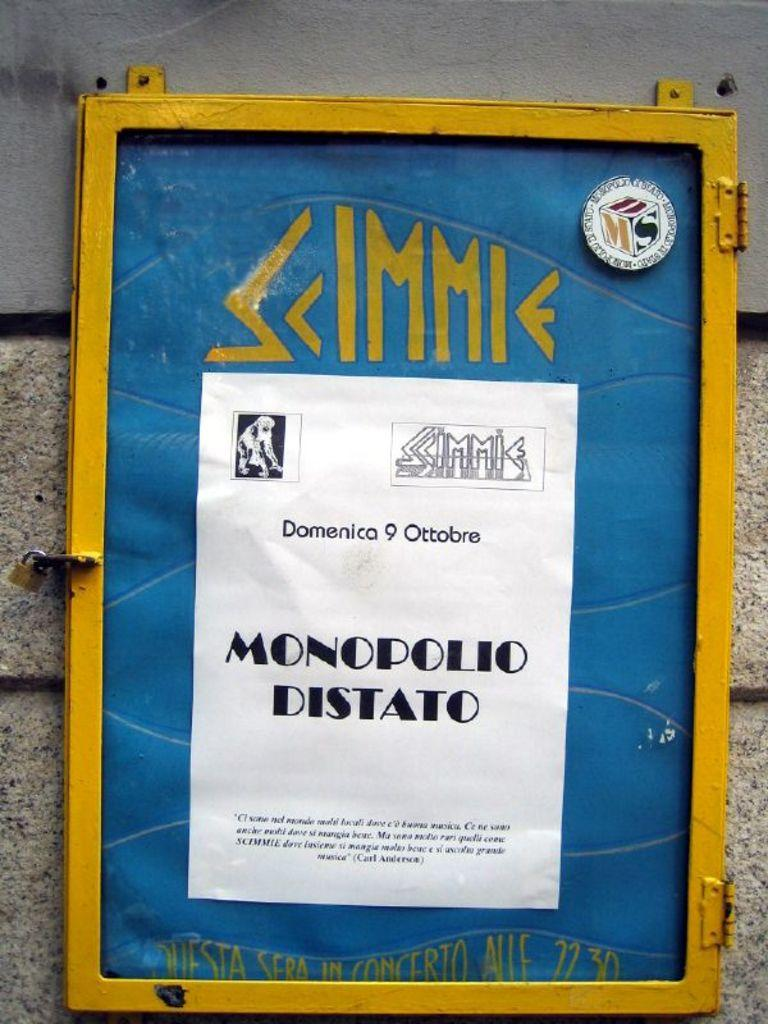What is attached to the wall in the image? There is a board on the wall in the image. What can be seen on the board? There is text written on the board. Is the board on the wall covered in dust in the image? There is no information about dust on the board in the image, so we cannot determine if it is covered in dust or not. 